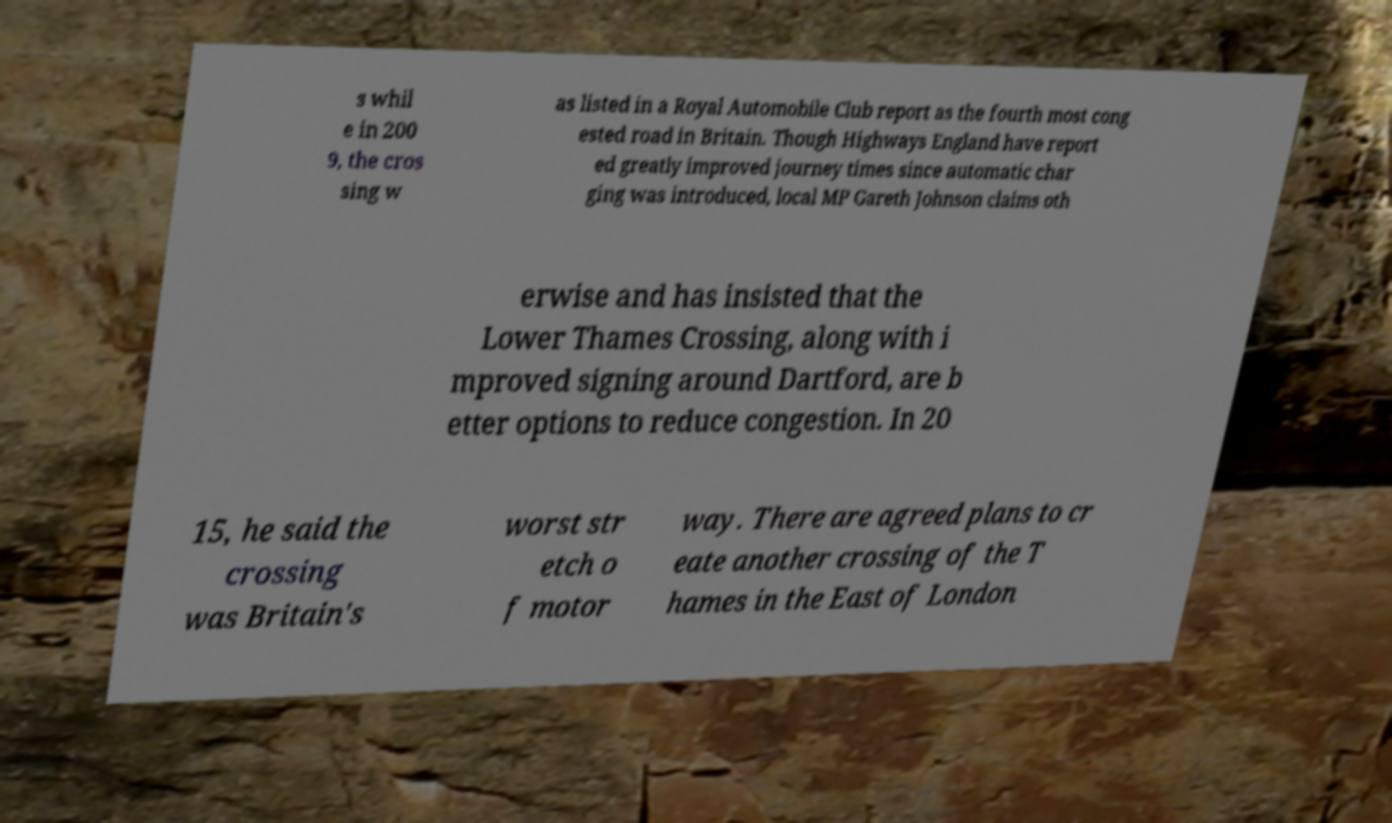Please read and relay the text visible in this image. What does it say? s whil e in 200 9, the cros sing w as listed in a Royal Automobile Club report as the fourth most cong ested road in Britain. Though Highways England have report ed greatly improved journey times since automatic char ging was introduced, local MP Gareth Johnson claims oth erwise and has insisted that the Lower Thames Crossing, along with i mproved signing around Dartford, are b etter options to reduce congestion. In 20 15, he said the crossing was Britain's worst str etch o f motor way. There are agreed plans to cr eate another crossing of the T hames in the East of London 